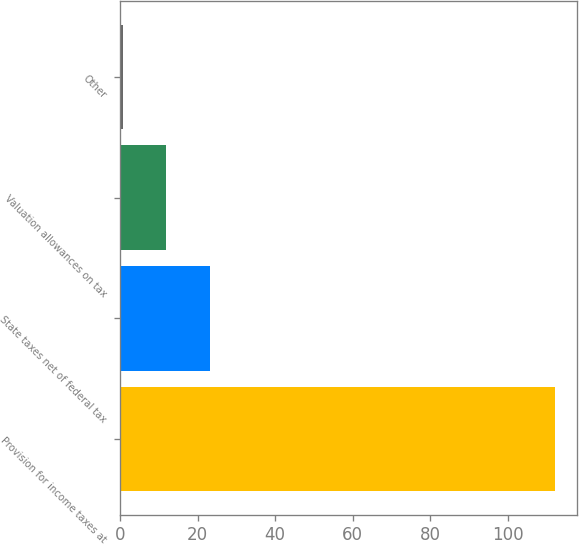Convert chart to OTSL. <chart><loc_0><loc_0><loc_500><loc_500><bar_chart><fcel>Provision for income taxes at<fcel>State taxes net of federal tax<fcel>Valuation allowances on tax<fcel>Other<nl><fcel>112.3<fcel>23.1<fcel>11.95<fcel>0.8<nl></chart> 